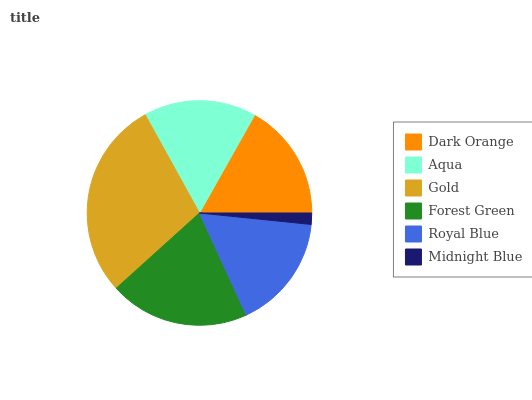Is Midnight Blue the minimum?
Answer yes or no. Yes. Is Gold the maximum?
Answer yes or no. Yes. Is Aqua the minimum?
Answer yes or no. No. Is Aqua the maximum?
Answer yes or no. No. Is Dark Orange greater than Aqua?
Answer yes or no. Yes. Is Aqua less than Dark Orange?
Answer yes or no. Yes. Is Aqua greater than Dark Orange?
Answer yes or no. No. Is Dark Orange less than Aqua?
Answer yes or no. No. Is Dark Orange the high median?
Answer yes or no. Yes. Is Royal Blue the low median?
Answer yes or no. Yes. Is Gold the high median?
Answer yes or no. No. Is Gold the low median?
Answer yes or no. No. 